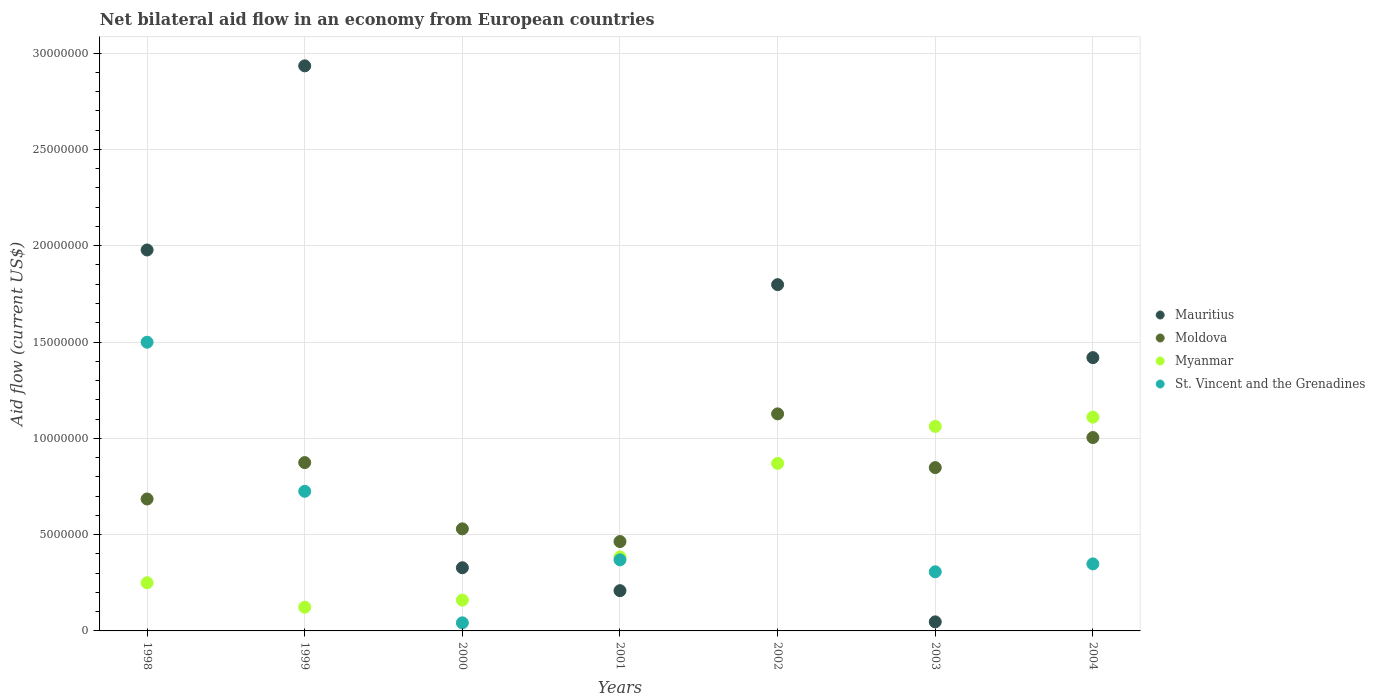How many different coloured dotlines are there?
Your response must be concise. 4. Is the number of dotlines equal to the number of legend labels?
Offer a terse response. No. What is the net bilateral aid flow in Myanmar in 1998?
Your answer should be compact. 2.50e+06. Across all years, what is the maximum net bilateral aid flow in St. Vincent and the Grenadines?
Your answer should be compact. 1.50e+07. Across all years, what is the minimum net bilateral aid flow in Mauritius?
Make the answer very short. 4.70e+05. What is the total net bilateral aid flow in Myanmar in the graph?
Keep it short and to the point. 3.96e+07. What is the difference between the net bilateral aid flow in St. Vincent and the Grenadines in 1998 and the net bilateral aid flow in Mauritius in 2002?
Make the answer very short. -2.99e+06. What is the average net bilateral aid flow in Myanmar per year?
Keep it short and to the point. 5.66e+06. In the year 2001, what is the difference between the net bilateral aid flow in St. Vincent and the Grenadines and net bilateral aid flow in Myanmar?
Provide a short and direct response. -1.50e+05. In how many years, is the net bilateral aid flow in Myanmar greater than 24000000 US$?
Make the answer very short. 0. What is the ratio of the net bilateral aid flow in Myanmar in 1998 to that in 1999?
Offer a very short reply. 2.03. What is the difference between the highest and the second highest net bilateral aid flow in St. Vincent and the Grenadines?
Your response must be concise. 7.74e+06. What is the difference between the highest and the lowest net bilateral aid flow in Mauritius?
Your response must be concise. 2.89e+07. In how many years, is the net bilateral aid flow in Myanmar greater than the average net bilateral aid flow in Myanmar taken over all years?
Keep it short and to the point. 3. Is it the case that in every year, the sum of the net bilateral aid flow in Moldova and net bilateral aid flow in St. Vincent and the Grenadines  is greater than the sum of net bilateral aid flow in Myanmar and net bilateral aid flow in Mauritius?
Ensure brevity in your answer.  No. Does the net bilateral aid flow in Myanmar monotonically increase over the years?
Offer a terse response. No. How many years are there in the graph?
Your response must be concise. 7. What is the difference between two consecutive major ticks on the Y-axis?
Your answer should be very brief. 5.00e+06. Where does the legend appear in the graph?
Ensure brevity in your answer.  Center right. How many legend labels are there?
Provide a succinct answer. 4. What is the title of the graph?
Your response must be concise. Net bilateral aid flow in an economy from European countries. What is the label or title of the X-axis?
Ensure brevity in your answer.  Years. What is the Aid flow (current US$) of Mauritius in 1998?
Your response must be concise. 1.98e+07. What is the Aid flow (current US$) in Moldova in 1998?
Ensure brevity in your answer.  6.85e+06. What is the Aid flow (current US$) in Myanmar in 1998?
Offer a very short reply. 2.50e+06. What is the Aid flow (current US$) in St. Vincent and the Grenadines in 1998?
Your answer should be compact. 1.50e+07. What is the Aid flow (current US$) in Mauritius in 1999?
Provide a succinct answer. 2.93e+07. What is the Aid flow (current US$) of Moldova in 1999?
Ensure brevity in your answer.  8.74e+06. What is the Aid flow (current US$) of Myanmar in 1999?
Give a very brief answer. 1.23e+06. What is the Aid flow (current US$) in St. Vincent and the Grenadines in 1999?
Your answer should be compact. 7.25e+06. What is the Aid flow (current US$) of Mauritius in 2000?
Offer a very short reply. 3.28e+06. What is the Aid flow (current US$) of Moldova in 2000?
Provide a succinct answer. 5.30e+06. What is the Aid flow (current US$) in Myanmar in 2000?
Provide a short and direct response. 1.60e+06. What is the Aid flow (current US$) in St. Vincent and the Grenadines in 2000?
Offer a terse response. 4.20e+05. What is the Aid flow (current US$) in Mauritius in 2001?
Your answer should be very brief. 2.09e+06. What is the Aid flow (current US$) of Moldova in 2001?
Offer a terse response. 4.64e+06. What is the Aid flow (current US$) of Myanmar in 2001?
Your answer should be compact. 3.84e+06. What is the Aid flow (current US$) in St. Vincent and the Grenadines in 2001?
Provide a succinct answer. 3.69e+06. What is the Aid flow (current US$) in Mauritius in 2002?
Give a very brief answer. 1.80e+07. What is the Aid flow (current US$) in Moldova in 2002?
Offer a very short reply. 1.13e+07. What is the Aid flow (current US$) in Myanmar in 2002?
Offer a very short reply. 8.70e+06. What is the Aid flow (current US$) in Mauritius in 2003?
Provide a succinct answer. 4.70e+05. What is the Aid flow (current US$) in Moldova in 2003?
Offer a very short reply. 8.48e+06. What is the Aid flow (current US$) in Myanmar in 2003?
Your answer should be very brief. 1.06e+07. What is the Aid flow (current US$) in St. Vincent and the Grenadines in 2003?
Your response must be concise. 3.07e+06. What is the Aid flow (current US$) in Mauritius in 2004?
Your answer should be very brief. 1.42e+07. What is the Aid flow (current US$) of Moldova in 2004?
Your response must be concise. 1.00e+07. What is the Aid flow (current US$) in Myanmar in 2004?
Keep it short and to the point. 1.11e+07. What is the Aid flow (current US$) of St. Vincent and the Grenadines in 2004?
Provide a succinct answer. 3.48e+06. Across all years, what is the maximum Aid flow (current US$) in Mauritius?
Offer a terse response. 2.93e+07. Across all years, what is the maximum Aid flow (current US$) in Moldova?
Your answer should be compact. 1.13e+07. Across all years, what is the maximum Aid flow (current US$) in Myanmar?
Your answer should be compact. 1.11e+07. Across all years, what is the maximum Aid flow (current US$) of St. Vincent and the Grenadines?
Make the answer very short. 1.50e+07. Across all years, what is the minimum Aid flow (current US$) in Moldova?
Your answer should be compact. 4.64e+06. Across all years, what is the minimum Aid flow (current US$) in Myanmar?
Your answer should be compact. 1.23e+06. What is the total Aid flow (current US$) in Mauritius in the graph?
Your answer should be very brief. 8.71e+07. What is the total Aid flow (current US$) in Moldova in the graph?
Make the answer very short. 5.53e+07. What is the total Aid flow (current US$) in Myanmar in the graph?
Make the answer very short. 3.96e+07. What is the total Aid flow (current US$) in St. Vincent and the Grenadines in the graph?
Your response must be concise. 3.29e+07. What is the difference between the Aid flow (current US$) of Mauritius in 1998 and that in 1999?
Your answer should be compact. -9.56e+06. What is the difference between the Aid flow (current US$) in Moldova in 1998 and that in 1999?
Offer a terse response. -1.89e+06. What is the difference between the Aid flow (current US$) of Myanmar in 1998 and that in 1999?
Keep it short and to the point. 1.27e+06. What is the difference between the Aid flow (current US$) of St. Vincent and the Grenadines in 1998 and that in 1999?
Provide a succinct answer. 7.74e+06. What is the difference between the Aid flow (current US$) of Mauritius in 1998 and that in 2000?
Offer a terse response. 1.65e+07. What is the difference between the Aid flow (current US$) in Moldova in 1998 and that in 2000?
Keep it short and to the point. 1.55e+06. What is the difference between the Aid flow (current US$) of St. Vincent and the Grenadines in 1998 and that in 2000?
Your answer should be very brief. 1.46e+07. What is the difference between the Aid flow (current US$) of Mauritius in 1998 and that in 2001?
Make the answer very short. 1.77e+07. What is the difference between the Aid flow (current US$) in Moldova in 1998 and that in 2001?
Your response must be concise. 2.21e+06. What is the difference between the Aid flow (current US$) of Myanmar in 1998 and that in 2001?
Give a very brief answer. -1.34e+06. What is the difference between the Aid flow (current US$) of St. Vincent and the Grenadines in 1998 and that in 2001?
Make the answer very short. 1.13e+07. What is the difference between the Aid flow (current US$) in Mauritius in 1998 and that in 2002?
Your answer should be compact. 1.80e+06. What is the difference between the Aid flow (current US$) in Moldova in 1998 and that in 2002?
Make the answer very short. -4.42e+06. What is the difference between the Aid flow (current US$) in Myanmar in 1998 and that in 2002?
Offer a very short reply. -6.20e+06. What is the difference between the Aid flow (current US$) in Mauritius in 1998 and that in 2003?
Make the answer very short. 1.93e+07. What is the difference between the Aid flow (current US$) of Moldova in 1998 and that in 2003?
Your answer should be compact. -1.63e+06. What is the difference between the Aid flow (current US$) in Myanmar in 1998 and that in 2003?
Your response must be concise. -8.12e+06. What is the difference between the Aid flow (current US$) of St. Vincent and the Grenadines in 1998 and that in 2003?
Your answer should be compact. 1.19e+07. What is the difference between the Aid flow (current US$) of Mauritius in 1998 and that in 2004?
Your answer should be very brief. 5.59e+06. What is the difference between the Aid flow (current US$) in Moldova in 1998 and that in 2004?
Keep it short and to the point. -3.19e+06. What is the difference between the Aid flow (current US$) of Myanmar in 1998 and that in 2004?
Ensure brevity in your answer.  -8.60e+06. What is the difference between the Aid flow (current US$) in St. Vincent and the Grenadines in 1998 and that in 2004?
Give a very brief answer. 1.15e+07. What is the difference between the Aid flow (current US$) in Mauritius in 1999 and that in 2000?
Offer a very short reply. 2.61e+07. What is the difference between the Aid flow (current US$) in Moldova in 1999 and that in 2000?
Your answer should be compact. 3.44e+06. What is the difference between the Aid flow (current US$) of Myanmar in 1999 and that in 2000?
Provide a short and direct response. -3.70e+05. What is the difference between the Aid flow (current US$) in St. Vincent and the Grenadines in 1999 and that in 2000?
Make the answer very short. 6.83e+06. What is the difference between the Aid flow (current US$) in Mauritius in 1999 and that in 2001?
Offer a terse response. 2.72e+07. What is the difference between the Aid flow (current US$) of Moldova in 1999 and that in 2001?
Offer a terse response. 4.10e+06. What is the difference between the Aid flow (current US$) of Myanmar in 1999 and that in 2001?
Ensure brevity in your answer.  -2.61e+06. What is the difference between the Aid flow (current US$) of St. Vincent and the Grenadines in 1999 and that in 2001?
Your response must be concise. 3.56e+06. What is the difference between the Aid flow (current US$) of Mauritius in 1999 and that in 2002?
Provide a succinct answer. 1.14e+07. What is the difference between the Aid flow (current US$) of Moldova in 1999 and that in 2002?
Your answer should be compact. -2.53e+06. What is the difference between the Aid flow (current US$) of Myanmar in 1999 and that in 2002?
Your answer should be very brief. -7.47e+06. What is the difference between the Aid flow (current US$) of Mauritius in 1999 and that in 2003?
Your answer should be compact. 2.89e+07. What is the difference between the Aid flow (current US$) in Moldova in 1999 and that in 2003?
Offer a terse response. 2.60e+05. What is the difference between the Aid flow (current US$) of Myanmar in 1999 and that in 2003?
Offer a very short reply. -9.39e+06. What is the difference between the Aid flow (current US$) of St. Vincent and the Grenadines in 1999 and that in 2003?
Make the answer very short. 4.18e+06. What is the difference between the Aid flow (current US$) in Mauritius in 1999 and that in 2004?
Offer a very short reply. 1.52e+07. What is the difference between the Aid flow (current US$) of Moldova in 1999 and that in 2004?
Offer a very short reply. -1.30e+06. What is the difference between the Aid flow (current US$) in Myanmar in 1999 and that in 2004?
Your response must be concise. -9.87e+06. What is the difference between the Aid flow (current US$) in St. Vincent and the Grenadines in 1999 and that in 2004?
Offer a terse response. 3.77e+06. What is the difference between the Aid flow (current US$) of Mauritius in 2000 and that in 2001?
Offer a very short reply. 1.19e+06. What is the difference between the Aid flow (current US$) in Myanmar in 2000 and that in 2001?
Your response must be concise. -2.24e+06. What is the difference between the Aid flow (current US$) of St. Vincent and the Grenadines in 2000 and that in 2001?
Ensure brevity in your answer.  -3.27e+06. What is the difference between the Aid flow (current US$) in Mauritius in 2000 and that in 2002?
Provide a succinct answer. -1.47e+07. What is the difference between the Aid flow (current US$) in Moldova in 2000 and that in 2002?
Your answer should be very brief. -5.97e+06. What is the difference between the Aid flow (current US$) in Myanmar in 2000 and that in 2002?
Offer a very short reply. -7.10e+06. What is the difference between the Aid flow (current US$) of Mauritius in 2000 and that in 2003?
Your response must be concise. 2.81e+06. What is the difference between the Aid flow (current US$) in Moldova in 2000 and that in 2003?
Your answer should be very brief. -3.18e+06. What is the difference between the Aid flow (current US$) of Myanmar in 2000 and that in 2003?
Your answer should be very brief. -9.02e+06. What is the difference between the Aid flow (current US$) in St. Vincent and the Grenadines in 2000 and that in 2003?
Ensure brevity in your answer.  -2.65e+06. What is the difference between the Aid flow (current US$) in Mauritius in 2000 and that in 2004?
Ensure brevity in your answer.  -1.09e+07. What is the difference between the Aid flow (current US$) in Moldova in 2000 and that in 2004?
Give a very brief answer. -4.74e+06. What is the difference between the Aid flow (current US$) in Myanmar in 2000 and that in 2004?
Provide a succinct answer. -9.50e+06. What is the difference between the Aid flow (current US$) in St. Vincent and the Grenadines in 2000 and that in 2004?
Your answer should be very brief. -3.06e+06. What is the difference between the Aid flow (current US$) of Mauritius in 2001 and that in 2002?
Your answer should be compact. -1.59e+07. What is the difference between the Aid flow (current US$) of Moldova in 2001 and that in 2002?
Your answer should be compact. -6.63e+06. What is the difference between the Aid flow (current US$) in Myanmar in 2001 and that in 2002?
Offer a terse response. -4.86e+06. What is the difference between the Aid flow (current US$) of Mauritius in 2001 and that in 2003?
Offer a terse response. 1.62e+06. What is the difference between the Aid flow (current US$) in Moldova in 2001 and that in 2003?
Make the answer very short. -3.84e+06. What is the difference between the Aid flow (current US$) in Myanmar in 2001 and that in 2003?
Make the answer very short. -6.78e+06. What is the difference between the Aid flow (current US$) of St. Vincent and the Grenadines in 2001 and that in 2003?
Your response must be concise. 6.20e+05. What is the difference between the Aid flow (current US$) of Mauritius in 2001 and that in 2004?
Keep it short and to the point. -1.21e+07. What is the difference between the Aid flow (current US$) of Moldova in 2001 and that in 2004?
Provide a succinct answer. -5.40e+06. What is the difference between the Aid flow (current US$) in Myanmar in 2001 and that in 2004?
Give a very brief answer. -7.26e+06. What is the difference between the Aid flow (current US$) of St. Vincent and the Grenadines in 2001 and that in 2004?
Your answer should be very brief. 2.10e+05. What is the difference between the Aid flow (current US$) in Mauritius in 2002 and that in 2003?
Provide a short and direct response. 1.75e+07. What is the difference between the Aid flow (current US$) of Moldova in 2002 and that in 2003?
Provide a succinct answer. 2.79e+06. What is the difference between the Aid flow (current US$) in Myanmar in 2002 and that in 2003?
Make the answer very short. -1.92e+06. What is the difference between the Aid flow (current US$) in Mauritius in 2002 and that in 2004?
Provide a short and direct response. 3.79e+06. What is the difference between the Aid flow (current US$) in Moldova in 2002 and that in 2004?
Keep it short and to the point. 1.23e+06. What is the difference between the Aid flow (current US$) in Myanmar in 2002 and that in 2004?
Offer a terse response. -2.40e+06. What is the difference between the Aid flow (current US$) in Mauritius in 2003 and that in 2004?
Ensure brevity in your answer.  -1.37e+07. What is the difference between the Aid flow (current US$) of Moldova in 2003 and that in 2004?
Provide a short and direct response. -1.56e+06. What is the difference between the Aid flow (current US$) of Myanmar in 2003 and that in 2004?
Provide a short and direct response. -4.80e+05. What is the difference between the Aid flow (current US$) of St. Vincent and the Grenadines in 2003 and that in 2004?
Offer a very short reply. -4.10e+05. What is the difference between the Aid flow (current US$) of Mauritius in 1998 and the Aid flow (current US$) of Moldova in 1999?
Give a very brief answer. 1.10e+07. What is the difference between the Aid flow (current US$) in Mauritius in 1998 and the Aid flow (current US$) in Myanmar in 1999?
Keep it short and to the point. 1.86e+07. What is the difference between the Aid flow (current US$) in Mauritius in 1998 and the Aid flow (current US$) in St. Vincent and the Grenadines in 1999?
Provide a succinct answer. 1.25e+07. What is the difference between the Aid flow (current US$) of Moldova in 1998 and the Aid flow (current US$) of Myanmar in 1999?
Provide a short and direct response. 5.62e+06. What is the difference between the Aid flow (current US$) of Moldova in 1998 and the Aid flow (current US$) of St. Vincent and the Grenadines in 1999?
Your answer should be compact. -4.00e+05. What is the difference between the Aid flow (current US$) of Myanmar in 1998 and the Aid flow (current US$) of St. Vincent and the Grenadines in 1999?
Your answer should be compact. -4.75e+06. What is the difference between the Aid flow (current US$) of Mauritius in 1998 and the Aid flow (current US$) of Moldova in 2000?
Offer a terse response. 1.45e+07. What is the difference between the Aid flow (current US$) in Mauritius in 1998 and the Aid flow (current US$) in Myanmar in 2000?
Your answer should be compact. 1.82e+07. What is the difference between the Aid flow (current US$) of Mauritius in 1998 and the Aid flow (current US$) of St. Vincent and the Grenadines in 2000?
Your answer should be compact. 1.94e+07. What is the difference between the Aid flow (current US$) in Moldova in 1998 and the Aid flow (current US$) in Myanmar in 2000?
Give a very brief answer. 5.25e+06. What is the difference between the Aid flow (current US$) in Moldova in 1998 and the Aid flow (current US$) in St. Vincent and the Grenadines in 2000?
Your answer should be compact. 6.43e+06. What is the difference between the Aid flow (current US$) in Myanmar in 1998 and the Aid flow (current US$) in St. Vincent and the Grenadines in 2000?
Your answer should be compact. 2.08e+06. What is the difference between the Aid flow (current US$) of Mauritius in 1998 and the Aid flow (current US$) of Moldova in 2001?
Offer a very short reply. 1.51e+07. What is the difference between the Aid flow (current US$) of Mauritius in 1998 and the Aid flow (current US$) of Myanmar in 2001?
Your answer should be compact. 1.59e+07. What is the difference between the Aid flow (current US$) of Mauritius in 1998 and the Aid flow (current US$) of St. Vincent and the Grenadines in 2001?
Your answer should be very brief. 1.61e+07. What is the difference between the Aid flow (current US$) of Moldova in 1998 and the Aid flow (current US$) of Myanmar in 2001?
Provide a succinct answer. 3.01e+06. What is the difference between the Aid flow (current US$) of Moldova in 1998 and the Aid flow (current US$) of St. Vincent and the Grenadines in 2001?
Keep it short and to the point. 3.16e+06. What is the difference between the Aid flow (current US$) in Myanmar in 1998 and the Aid flow (current US$) in St. Vincent and the Grenadines in 2001?
Your response must be concise. -1.19e+06. What is the difference between the Aid flow (current US$) of Mauritius in 1998 and the Aid flow (current US$) of Moldova in 2002?
Offer a very short reply. 8.51e+06. What is the difference between the Aid flow (current US$) in Mauritius in 1998 and the Aid flow (current US$) in Myanmar in 2002?
Keep it short and to the point. 1.11e+07. What is the difference between the Aid flow (current US$) in Moldova in 1998 and the Aid flow (current US$) in Myanmar in 2002?
Give a very brief answer. -1.85e+06. What is the difference between the Aid flow (current US$) of Mauritius in 1998 and the Aid flow (current US$) of Moldova in 2003?
Make the answer very short. 1.13e+07. What is the difference between the Aid flow (current US$) in Mauritius in 1998 and the Aid flow (current US$) in Myanmar in 2003?
Ensure brevity in your answer.  9.16e+06. What is the difference between the Aid flow (current US$) of Mauritius in 1998 and the Aid flow (current US$) of St. Vincent and the Grenadines in 2003?
Provide a short and direct response. 1.67e+07. What is the difference between the Aid flow (current US$) of Moldova in 1998 and the Aid flow (current US$) of Myanmar in 2003?
Give a very brief answer. -3.77e+06. What is the difference between the Aid flow (current US$) in Moldova in 1998 and the Aid flow (current US$) in St. Vincent and the Grenadines in 2003?
Keep it short and to the point. 3.78e+06. What is the difference between the Aid flow (current US$) of Myanmar in 1998 and the Aid flow (current US$) of St. Vincent and the Grenadines in 2003?
Your answer should be very brief. -5.70e+05. What is the difference between the Aid flow (current US$) of Mauritius in 1998 and the Aid flow (current US$) of Moldova in 2004?
Provide a short and direct response. 9.74e+06. What is the difference between the Aid flow (current US$) in Mauritius in 1998 and the Aid flow (current US$) in Myanmar in 2004?
Keep it short and to the point. 8.68e+06. What is the difference between the Aid flow (current US$) in Mauritius in 1998 and the Aid flow (current US$) in St. Vincent and the Grenadines in 2004?
Provide a succinct answer. 1.63e+07. What is the difference between the Aid flow (current US$) in Moldova in 1998 and the Aid flow (current US$) in Myanmar in 2004?
Your response must be concise. -4.25e+06. What is the difference between the Aid flow (current US$) of Moldova in 1998 and the Aid flow (current US$) of St. Vincent and the Grenadines in 2004?
Your answer should be very brief. 3.37e+06. What is the difference between the Aid flow (current US$) in Myanmar in 1998 and the Aid flow (current US$) in St. Vincent and the Grenadines in 2004?
Your response must be concise. -9.80e+05. What is the difference between the Aid flow (current US$) in Mauritius in 1999 and the Aid flow (current US$) in Moldova in 2000?
Your response must be concise. 2.40e+07. What is the difference between the Aid flow (current US$) in Mauritius in 1999 and the Aid flow (current US$) in Myanmar in 2000?
Make the answer very short. 2.77e+07. What is the difference between the Aid flow (current US$) of Mauritius in 1999 and the Aid flow (current US$) of St. Vincent and the Grenadines in 2000?
Your answer should be compact. 2.89e+07. What is the difference between the Aid flow (current US$) in Moldova in 1999 and the Aid flow (current US$) in Myanmar in 2000?
Give a very brief answer. 7.14e+06. What is the difference between the Aid flow (current US$) in Moldova in 1999 and the Aid flow (current US$) in St. Vincent and the Grenadines in 2000?
Ensure brevity in your answer.  8.32e+06. What is the difference between the Aid flow (current US$) in Myanmar in 1999 and the Aid flow (current US$) in St. Vincent and the Grenadines in 2000?
Give a very brief answer. 8.10e+05. What is the difference between the Aid flow (current US$) of Mauritius in 1999 and the Aid flow (current US$) of Moldova in 2001?
Your response must be concise. 2.47e+07. What is the difference between the Aid flow (current US$) of Mauritius in 1999 and the Aid flow (current US$) of Myanmar in 2001?
Ensure brevity in your answer.  2.55e+07. What is the difference between the Aid flow (current US$) in Mauritius in 1999 and the Aid flow (current US$) in St. Vincent and the Grenadines in 2001?
Keep it short and to the point. 2.56e+07. What is the difference between the Aid flow (current US$) of Moldova in 1999 and the Aid flow (current US$) of Myanmar in 2001?
Make the answer very short. 4.90e+06. What is the difference between the Aid flow (current US$) in Moldova in 1999 and the Aid flow (current US$) in St. Vincent and the Grenadines in 2001?
Ensure brevity in your answer.  5.05e+06. What is the difference between the Aid flow (current US$) of Myanmar in 1999 and the Aid flow (current US$) of St. Vincent and the Grenadines in 2001?
Provide a short and direct response. -2.46e+06. What is the difference between the Aid flow (current US$) in Mauritius in 1999 and the Aid flow (current US$) in Moldova in 2002?
Provide a short and direct response. 1.81e+07. What is the difference between the Aid flow (current US$) in Mauritius in 1999 and the Aid flow (current US$) in Myanmar in 2002?
Give a very brief answer. 2.06e+07. What is the difference between the Aid flow (current US$) in Moldova in 1999 and the Aid flow (current US$) in Myanmar in 2002?
Provide a succinct answer. 4.00e+04. What is the difference between the Aid flow (current US$) of Mauritius in 1999 and the Aid flow (current US$) of Moldova in 2003?
Your response must be concise. 2.09e+07. What is the difference between the Aid flow (current US$) of Mauritius in 1999 and the Aid flow (current US$) of Myanmar in 2003?
Make the answer very short. 1.87e+07. What is the difference between the Aid flow (current US$) of Mauritius in 1999 and the Aid flow (current US$) of St. Vincent and the Grenadines in 2003?
Ensure brevity in your answer.  2.63e+07. What is the difference between the Aid flow (current US$) of Moldova in 1999 and the Aid flow (current US$) of Myanmar in 2003?
Provide a succinct answer. -1.88e+06. What is the difference between the Aid flow (current US$) of Moldova in 1999 and the Aid flow (current US$) of St. Vincent and the Grenadines in 2003?
Provide a short and direct response. 5.67e+06. What is the difference between the Aid flow (current US$) of Myanmar in 1999 and the Aid flow (current US$) of St. Vincent and the Grenadines in 2003?
Make the answer very short. -1.84e+06. What is the difference between the Aid flow (current US$) of Mauritius in 1999 and the Aid flow (current US$) of Moldova in 2004?
Your answer should be compact. 1.93e+07. What is the difference between the Aid flow (current US$) in Mauritius in 1999 and the Aid flow (current US$) in Myanmar in 2004?
Offer a very short reply. 1.82e+07. What is the difference between the Aid flow (current US$) in Mauritius in 1999 and the Aid flow (current US$) in St. Vincent and the Grenadines in 2004?
Make the answer very short. 2.59e+07. What is the difference between the Aid flow (current US$) in Moldova in 1999 and the Aid flow (current US$) in Myanmar in 2004?
Ensure brevity in your answer.  -2.36e+06. What is the difference between the Aid flow (current US$) of Moldova in 1999 and the Aid flow (current US$) of St. Vincent and the Grenadines in 2004?
Make the answer very short. 5.26e+06. What is the difference between the Aid flow (current US$) in Myanmar in 1999 and the Aid flow (current US$) in St. Vincent and the Grenadines in 2004?
Your answer should be compact. -2.25e+06. What is the difference between the Aid flow (current US$) in Mauritius in 2000 and the Aid flow (current US$) in Moldova in 2001?
Provide a short and direct response. -1.36e+06. What is the difference between the Aid flow (current US$) in Mauritius in 2000 and the Aid flow (current US$) in Myanmar in 2001?
Offer a very short reply. -5.60e+05. What is the difference between the Aid flow (current US$) in Mauritius in 2000 and the Aid flow (current US$) in St. Vincent and the Grenadines in 2001?
Your answer should be compact. -4.10e+05. What is the difference between the Aid flow (current US$) of Moldova in 2000 and the Aid flow (current US$) of Myanmar in 2001?
Offer a terse response. 1.46e+06. What is the difference between the Aid flow (current US$) of Moldova in 2000 and the Aid flow (current US$) of St. Vincent and the Grenadines in 2001?
Offer a terse response. 1.61e+06. What is the difference between the Aid flow (current US$) of Myanmar in 2000 and the Aid flow (current US$) of St. Vincent and the Grenadines in 2001?
Provide a short and direct response. -2.09e+06. What is the difference between the Aid flow (current US$) of Mauritius in 2000 and the Aid flow (current US$) of Moldova in 2002?
Provide a short and direct response. -7.99e+06. What is the difference between the Aid flow (current US$) in Mauritius in 2000 and the Aid flow (current US$) in Myanmar in 2002?
Provide a succinct answer. -5.42e+06. What is the difference between the Aid flow (current US$) in Moldova in 2000 and the Aid flow (current US$) in Myanmar in 2002?
Ensure brevity in your answer.  -3.40e+06. What is the difference between the Aid flow (current US$) of Mauritius in 2000 and the Aid flow (current US$) of Moldova in 2003?
Provide a succinct answer. -5.20e+06. What is the difference between the Aid flow (current US$) in Mauritius in 2000 and the Aid flow (current US$) in Myanmar in 2003?
Provide a short and direct response. -7.34e+06. What is the difference between the Aid flow (current US$) in Mauritius in 2000 and the Aid flow (current US$) in St. Vincent and the Grenadines in 2003?
Your answer should be very brief. 2.10e+05. What is the difference between the Aid flow (current US$) in Moldova in 2000 and the Aid flow (current US$) in Myanmar in 2003?
Provide a short and direct response. -5.32e+06. What is the difference between the Aid flow (current US$) of Moldova in 2000 and the Aid flow (current US$) of St. Vincent and the Grenadines in 2003?
Your response must be concise. 2.23e+06. What is the difference between the Aid flow (current US$) of Myanmar in 2000 and the Aid flow (current US$) of St. Vincent and the Grenadines in 2003?
Offer a very short reply. -1.47e+06. What is the difference between the Aid flow (current US$) of Mauritius in 2000 and the Aid flow (current US$) of Moldova in 2004?
Offer a very short reply. -6.76e+06. What is the difference between the Aid flow (current US$) of Mauritius in 2000 and the Aid flow (current US$) of Myanmar in 2004?
Your answer should be very brief. -7.82e+06. What is the difference between the Aid flow (current US$) in Moldova in 2000 and the Aid flow (current US$) in Myanmar in 2004?
Ensure brevity in your answer.  -5.80e+06. What is the difference between the Aid flow (current US$) in Moldova in 2000 and the Aid flow (current US$) in St. Vincent and the Grenadines in 2004?
Your answer should be very brief. 1.82e+06. What is the difference between the Aid flow (current US$) of Myanmar in 2000 and the Aid flow (current US$) of St. Vincent and the Grenadines in 2004?
Provide a succinct answer. -1.88e+06. What is the difference between the Aid flow (current US$) in Mauritius in 2001 and the Aid flow (current US$) in Moldova in 2002?
Your answer should be very brief. -9.18e+06. What is the difference between the Aid flow (current US$) of Mauritius in 2001 and the Aid flow (current US$) of Myanmar in 2002?
Provide a short and direct response. -6.61e+06. What is the difference between the Aid flow (current US$) of Moldova in 2001 and the Aid flow (current US$) of Myanmar in 2002?
Provide a succinct answer. -4.06e+06. What is the difference between the Aid flow (current US$) of Mauritius in 2001 and the Aid flow (current US$) of Moldova in 2003?
Your answer should be compact. -6.39e+06. What is the difference between the Aid flow (current US$) of Mauritius in 2001 and the Aid flow (current US$) of Myanmar in 2003?
Offer a terse response. -8.53e+06. What is the difference between the Aid flow (current US$) in Mauritius in 2001 and the Aid flow (current US$) in St. Vincent and the Grenadines in 2003?
Your answer should be compact. -9.80e+05. What is the difference between the Aid flow (current US$) in Moldova in 2001 and the Aid flow (current US$) in Myanmar in 2003?
Your answer should be compact. -5.98e+06. What is the difference between the Aid flow (current US$) in Moldova in 2001 and the Aid flow (current US$) in St. Vincent and the Grenadines in 2003?
Your answer should be very brief. 1.57e+06. What is the difference between the Aid flow (current US$) of Myanmar in 2001 and the Aid flow (current US$) of St. Vincent and the Grenadines in 2003?
Provide a succinct answer. 7.70e+05. What is the difference between the Aid flow (current US$) in Mauritius in 2001 and the Aid flow (current US$) in Moldova in 2004?
Offer a terse response. -7.95e+06. What is the difference between the Aid flow (current US$) of Mauritius in 2001 and the Aid flow (current US$) of Myanmar in 2004?
Provide a succinct answer. -9.01e+06. What is the difference between the Aid flow (current US$) in Mauritius in 2001 and the Aid flow (current US$) in St. Vincent and the Grenadines in 2004?
Ensure brevity in your answer.  -1.39e+06. What is the difference between the Aid flow (current US$) of Moldova in 2001 and the Aid flow (current US$) of Myanmar in 2004?
Make the answer very short. -6.46e+06. What is the difference between the Aid flow (current US$) in Moldova in 2001 and the Aid flow (current US$) in St. Vincent and the Grenadines in 2004?
Provide a succinct answer. 1.16e+06. What is the difference between the Aid flow (current US$) in Mauritius in 2002 and the Aid flow (current US$) in Moldova in 2003?
Make the answer very short. 9.50e+06. What is the difference between the Aid flow (current US$) of Mauritius in 2002 and the Aid flow (current US$) of Myanmar in 2003?
Your response must be concise. 7.36e+06. What is the difference between the Aid flow (current US$) of Mauritius in 2002 and the Aid flow (current US$) of St. Vincent and the Grenadines in 2003?
Give a very brief answer. 1.49e+07. What is the difference between the Aid flow (current US$) of Moldova in 2002 and the Aid flow (current US$) of Myanmar in 2003?
Provide a short and direct response. 6.50e+05. What is the difference between the Aid flow (current US$) of Moldova in 2002 and the Aid flow (current US$) of St. Vincent and the Grenadines in 2003?
Provide a succinct answer. 8.20e+06. What is the difference between the Aid flow (current US$) in Myanmar in 2002 and the Aid flow (current US$) in St. Vincent and the Grenadines in 2003?
Ensure brevity in your answer.  5.63e+06. What is the difference between the Aid flow (current US$) in Mauritius in 2002 and the Aid flow (current US$) in Moldova in 2004?
Provide a succinct answer. 7.94e+06. What is the difference between the Aid flow (current US$) of Mauritius in 2002 and the Aid flow (current US$) of Myanmar in 2004?
Ensure brevity in your answer.  6.88e+06. What is the difference between the Aid flow (current US$) in Mauritius in 2002 and the Aid flow (current US$) in St. Vincent and the Grenadines in 2004?
Your answer should be very brief. 1.45e+07. What is the difference between the Aid flow (current US$) in Moldova in 2002 and the Aid flow (current US$) in St. Vincent and the Grenadines in 2004?
Ensure brevity in your answer.  7.79e+06. What is the difference between the Aid flow (current US$) of Myanmar in 2002 and the Aid flow (current US$) of St. Vincent and the Grenadines in 2004?
Offer a terse response. 5.22e+06. What is the difference between the Aid flow (current US$) in Mauritius in 2003 and the Aid flow (current US$) in Moldova in 2004?
Your answer should be compact. -9.57e+06. What is the difference between the Aid flow (current US$) in Mauritius in 2003 and the Aid flow (current US$) in Myanmar in 2004?
Provide a succinct answer. -1.06e+07. What is the difference between the Aid flow (current US$) in Mauritius in 2003 and the Aid flow (current US$) in St. Vincent and the Grenadines in 2004?
Your answer should be very brief. -3.01e+06. What is the difference between the Aid flow (current US$) of Moldova in 2003 and the Aid flow (current US$) of Myanmar in 2004?
Your answer should be compact. -2.62e+06. What is the difference between the Aid flow (current US$) of Moldova in 2003 and the Aid flow (current US$) of St. Vincent and the Grenadines in 2004?
Your answer should be compact. 5.00e+06. What is the difference between the Aid flow (current US$) of Myanmar in 2003 and the Aid flow (current US$) of St. Vincent and the Grenadines in 2004?
Make the answer very short. 7.14e+06. What is the average Aid flow (current US$) of Mauritius per year?
Give a very brief answer. 1.24e+07. What is the average Aid flow (current US$) in Moldova per year?
Offer a very short reply. 7.90e+06. What is the average Aid flow (current US$) of Myanmar per year?
Provide a short and direct response. 5.66e+06. What is the average Aid flow (current US$) of St. Vincent and the Grenadines per year?
Ensure brevity in your answer.  4.70e+06. In the year 1998, what is the difference between the Aid flow (current US$) of Mauritius and Aid flow (current US$) of Moldova?
Keep it short and to the point. 1.29e+07. In the year 1998, what is the difference between the Aid flow (current US$) in Mauritius and Aid flow (current US$) in Myanmar?
Offer a very short reply. 1.73e+07. In the year 1998, what is the difference between the Aid flow (current US$) of Mauritius and Aid flow (current US$) of St. Vincent and the Grenadines?
Your answer should be very brief. 4.79e+06. In the year 1998, what is the difference between the Aid flow (current US$) in Moldova and Aid flow (current US$) in Myanmar?
Offer a terse response. 4.35e+06. In the year 1998, what is the difference between the Aid flow (current US$) in Moldova and Aid flow (current US$) in St. Vincent and the Grenadines?
Offer a very short reply. -8.14e+06. In the year 1998, what is the difference between the Aid flow (current US$) of Myanmar and Aid flow (current US$) of St. Vincent and the Grenadines?
Ensure brevity in your answer.  -1.25e+07. In the year 1999, what is the difference between the Aid flow (current US$) of Mauritius and Aid flow (current US$) of Moldova?
Offer a terse response. 2.06e+07. In the year 1999, what is the difference between the Aid flow (current US$) of Mauritius and Aid flow (current US$) of Myanmar?
Your answer should be very brief. 2.81e+07. In the year 1999, what is the difference between the Aid flow (current US$) in Mauritius and Aid flow (current US$) in St. Vincent and the Grenadines?
Make the answer very short. 2.21e+07. In the year 1999, what is the difference between the Aid flow (current US$) of Moldova and Aid flow (current US$) of Myanmar?
Offer a terse response. 7.51e+06. In the year 1999, what is the difference between the Aid flow (current US$) of Moldova and Aid flow (current US$) of St. Vincent and the Grenadines?
Provide a short and direct response. 1.49e+06. In the year 1999, what is the difference between the Aid flow (current US$) of Myanmar and Aid flow (current US$) of St. Vincent and the Grenadines?
Provide a succinct answer. -6.02e+06. In the year 2000, what is the difference between the Aid flow (current US$) of Mauritius and Aid flow (current US$) of Moldova?
Provide a succinct answer. -2.02e+06. In the year 2000, what is the difference between the Aid flow (current US$) in Mauritius and Aid flow (current US$) in Myanmar?
Keep it short and to the point. 1.68e+06. In the year 2000, what is the difference between the Aid flow (current US$) of Mauritius and Aid flow (current US$) of St. Vincent and the Grenadines?
Offer a very short reply. 2.86e+06. In the year 2000, what is the difference between the Aid flow (current US$) of Moldova and Aid flow (current US$) of Myanmar?
Provide a succinct answer. 3.70e+06. In the year 2000, what is the difference between the Aid flow (current US$) in Moldova and Aid flow (current US$) in St. Vincent and the Grenadines?
Provide a succinct answer. 4.88e+06. In the year 2000, what is the difference between the Aid flow (current US$) of Myanmar and Aid flow (current US$) of St. Vincent and the Grenadines?
Your answer should be compact. 1.18e+06. In the year 2001, what is the difference between the Aid flow (current US$) of Mauritius and Aid flow (current US$) of Moldova?
Provide a short and direct response. -2.55e+06. In the year 2001, what is the difference between the Aid flow (current US$) in Mauritius and Aid flow (current US$) in Myanmar?
Provide a succinct answer. -1.75e+06. In the year 2001, what is the difference between the Aid flow (current US$) in Mauritius and Aid flow (current US$) in St. Vincent and the Grenadines?
Offer a very short reply. -1.60e+06. In the year 2001, what is the difference between the Aid flow (current US$) of Moldova and Aid flow (current US$) of Myanmar?
Your response must be concise. 8.00e+05. In the year 2001, what is the difference between the Aid flow (current US$) in Moldova and Aid flow (current US$) in St. Vincent and the Grenadines?
Offer a very short reply. 9.50e+05. In the year 2002, what is the difference between the Aid flow (current US$) of Mauritius and Aid flow (current US$) of Moldova?
Make the answer very short. 6.71e+06. In the year 2002, what is the difference between the Aid flow (current US$) of Mauritius and Aid flow (current US$) of Myanmar?
Make the answer very short. 9.28e+06. In the year 2002, what is the difference between the Aid flow (current US$) of Moldova and Aid flow (current US$) of Myanmar?
Your answer should be very brief. 2.57e+06. In the year 2003, what is the difference between the Aid flow (current US$) in Mauritius and Aid flow (current US$) in Moldova?
Give a very brief answer. -8.01e+06. In the year 2003, what is the difference between the Aid flow (current US$) in Mauritius and Aid flow (current US$) in Myanmar?
Your response must be concise. -1.02e+07. In the year 2003, what is the difference between the Aid flow (current US$) in Mauritius and Aid flow (current US$) in St. Vincent and the Grenadines?
Your answer should be compact. -2.60e+06. In the year 2003, what is the difference between the Aid flow (current US$) in Moldova and Aid flow (current US$) in Myanmar?
Your response must be concise. -2.14e+06. In the year 2003, what is the difference between the Aid flow (current US$) of Moldova and Aid flow (current US$) of St. Vincent and the Grenadines?
Make the answer very short. 5.41e+06. In the year 2003, what is the difference between the Aid flow (current US$) of Myanmar and Aid flow (current US$) of St. Vincent and the Grenadines?
Give a very brief answer. 7.55e+06. In the year 2004, what is the difference between the Aid flow (current US$) in Mauritius and Aid flow (current US$) in Moldova?
Your answer should be very brief. 4.15e+06. In the year 2004, what is the difference between the Aid flow (current US$) of Mauritius and Aid flow (current US$) of Myanmar?
Your response must be concise. 3.09e+06. In the year 2004, what is the difference between the Aid flow (current US$) of Mauritius and Aid flow (current US$) of St. Vincent and the Grenadines?
Give a very brief answer. 1.07e+07. In the year 2004, what is the difference between the Aid flow (current US$) in Moldova and Aid flow (current US$) in Myanmar?
Provide a succinct answer. -1.06e+06. In the year 2004, what is the difference between the Aid flow (current US$) of Moldova and Aid flow (current US$) of St. Vincent and the Grenadines?
Keep it short and to the point. 6.56e+06. In the year 2004, what is the difference between the Aid flow (current US$) in Myanmar and Aid flow (current US$) in St. Vincent and the Grenadines?
Provide a short and direct response. 7.62e+06. What is the ratio of the Aid flow (current US$) in Mauritius in 1998 to that in 1999?
Keep it short and to the point. 0.67. What is the ratio of the Aid flow (current US$) in Moldova in 1998 to that in 1999?
Keep it short and to the point. 0.78. What is the ratio of the Aid flow (current US$) in Myanmar in 1998 to that in 1999?
Your response must be concise. 2.03. What is the ratio of the Aid flow (current US$) of St. Vincent and the Grenadines in 1998 to that in 1999?
Your response must be concise. 2.07. What is the ratio of the Aid flow (current US$) of Mauritius in 1998 to that in 2000?
Your response must be concise. 6.03. What is the ratio of the Aid flow (current US$) of Moldova in 1998 to that in 2000?
Provide a succinct answer. 1.29. What is the ratio of the Aid flow (current US$) of Myanmar in 1998 to that in 2000?
Your response must be concise. 1.56. What is the ratio of the Aid flow (current US$) in St. Vincent and the Grenadines in 1998 to that in 2000?
Offer a terse response. 35.69. What is the ratio of the Aid flow (current US$) in Mauritius in 1998 to that in 2001?
Give a very brief answer. 9.46. What is the ratio of the Aid flow (current US$) of Moldova in 1998 to that in 2001?
Provide a short and direct response. 1.48. What is the ratio of the Aid flow (current US$) in Myanmar in 1998 to that in 2001?
Offer a very short reply. 0.65. What is the ratio of the Aid flow (current US$) of St. Vincent and the Grenadines in 1998 to that in 2001?
Make the answer very short. 4.06. What is the ratio of the Aid flow (current US$) in Mauritius in 1998 to that in 2002?
Offer a terse response. 1.1. What is the ratio of the Aid flow (current US$) of Moldova in 1998 to that in 2002?
Offer a very short reply. 0.61. What is the ratio of the Aid flow (current US$) in Myanmar in 1998 to that in 2002?
Make the answer very short. 0.29. What is the ratio of the Aid flow (current US$) of Mauritius in 1998 to that in 2003?
Keep it short and to the point. 42.09. What is the ratio of the Aid flow (current US$) of Moldova in 1998 to that in 2003?
Your answer should be very brief. 0.81. What is the ratio of the Aid flow (current US$) in Myanmar in 1998 to that in 2003?
Provide a short and direct response. 0.24. What is the ratio of the Aid flow (current US$) of St. Vincent and the Grenadines in 1998 to that in 2003?
Offer a very short reply. 4.88. What is the ratio of the Aid flow (current US$) in Mauritius in 1998 to that in 2004?
Offer a terse response. 1.39. What is the ratio of the Aid flow (current US$) in Moldova in 1998 to that in 2004?
Your response must be concise. 0.68. What is the ratio of the Aid flow (current US$) of Myanmar in 1998 to that in 2004?
Make the answer very short. 0.23. What is the ratio of the Aid flow (current US$) of St. Vincent and the Grenadines in 1998 to that in 2004?
Keep it short and to the point. 4.31. What is the ratio of the Aid flow (current US$) in Mauritius in 1999 to that in 2000?
Your response must be concise. 8.95. What is the ratio of the Aid flow (current US$) in Moldova in 1999 to that in 2000?
Your answer should be very brief. 1.65. What is the ratio of the Aid flow (current US$) of Myanmar in 1999 to that in 2000?
Offer a terse response. 0.77. What is the ratio of the Aid flow (current US$) in St. Vincent and the Grenadines in 1999 to that in 2000?
Offer a terse response. 17.26. What is the ratio of the Aid flow (current US$) in Mauritius in 1999 to that in 2001?
Offer a terse response. 14.04. What is the ratio of the Aid flow (current US$) in Moldova in 1999 to that in 2001?
Your answer should be compact. 1.88. What is the ratio of the Aid flow (current US$) in Myanmar in 1999 to that in 2001?
Offer a very short reply. 0.32. What is the ratio of the Aid flow (current US$) of St. Vincent and the Grenadines in 1999 to that in 2001?
Keep it short and to the point. 1.96. What is the ratio of the Aid flow (current US$) of Mauritius in 1999 to that in 2002?
Offer a very short reply. 1.63. What is the ratio of the Aid flow (current US$) in Moldova in 1999 to that in 2002?
Make the answer very short. 0.78. What is the ratio of the Aid flow (current US$) in Myanmar in 1999 to that in 2002?
Your answer should be very brief. 0.14. What is the ratio of the Aid flow (current US$) of Mauritius in 1999 to that in 2003?
Your answer should be compact. 62.43. What is the ratio of the Aid flow (current US$) in Moldova in 1999 to that in 2003?
Your response must be concise. 1.03. What is the ratio of the Aid flow (current US$) of Myanmar in 1999 to that in 2003?
Ensure brevity in your answer.  0.12. What is the ratio of the Aid flow (current US$) of St. Vincent and the Grenadines in 1999 to that in 2003?
Provide a succinct answer. 2.36. What is the ratio of the Aid flow (current US$) in Mauritius in 1999 to that in 2004?
Provide a succinct answer. 2.07. What is the ratio of the Aid flow (current US$) of Moldova in 1999 to that in 2004?
Your response must be concise. 0.87. What is the ratio of the Aid flow (current US$) in Myanmar in 1999 to that in 2004?
Provide a succinct answer. 0.11. What is the ratio of the Aid flow (current US$) of St. Vincent and the Grenadines in 1999 to that in 2004?
Provide a succinct answer. 2.08. What is the ratio of the Aid flow (current US$) of Mauritius in 2000 to that in 2001?
Your response must be concise. 1.57. What is the ratio of the Aid flow (current US$) of Moldova in 2000 to that in 2001?
Provide a succinct answer. 1.14. What is the ratio of the Aid flow (current US$) in Myanmar in 2000 to that in 2001?
Offer a very short reply. 0.42. What is the ratio of the Aid flow (current US$) in St. Vincent and the Grenadines in 2000 to that in 2001?
Offer a very short reply. 0.11. What is the ratio of the Aid flow (current US$) of Mauritius in 2000 to that in 2002?
Make the answer very short. 0.18. What is the ratio of the Aid flow (current US$) of Moldova in 2000 to that in 2002?
Provide a succinct answer. 0.47. What is the ratio of the Aid flow (current US$) of Myanmar in 2000 to that in 2002?
Provide a succinct answer. 0.18. What is the ratio of the Aid flow (current US$) in Mauritius in 2000 to that in 2003?
Your response must be concise. 6.98. What is the ratio of the Aid flow (current US$) of Moldova in 2000 to that in 2003?
Your answer should be very brief. 0.62. What is the ratio of the Aid flow (current US$) in Myanmar in 2000 to that in 2003?
Offer a very short reply. 0.15. What is the ratio of the Aid flow (current US$) in St. Vincent and the Grenadines in 2000 to that in 2003?
Offer a terse response. 0.14. What is the ratio of the Aid flow (current US$) in Mauritius in 2000 to that in 2004?
Make the answer very short. 0.23. What is the ratio of the Aid flow (current US$) of Moldova in 2000 to that in 2004?
Your answer should be very brief. 0.53. What is the ratio of the Aid flow (current US$) of Myanmar in 2000 to that in 2004?
Your response must be concise. 0.14. What is the ratio of the Aid flow (current US$) of St. Vincent and the Grenadines in 2000 to that in 2004?
Your answer should be very brief. 0.12. What is the ratio of the Aid flow (current US$) in Mauritius in 2001 to that in 2002?
Your response must be concise. 0.12. What is the ratio of the Aid flow (current US$) in Moldova in 2001 to that in 2002?
Make the answer very short. 0.41. What is the ratio of the Aid flow (current US$) in Myanmar in 2001 to that in 2002?
Make the answer very short. 0.44. What is the ratio of the Aid flow (current US$) of Mauritius in 2001 to that in 2003?
Keep it short and to the point. 4.45. What is the ratio of the Aid flow (current US$) of Moldova in 2001 to that in 2003?
Provide a short and direct response. 0.55. What is the ratio of the Aid flow (current US$) in Myanmar in 2001 to that in 2003?
Ensure brevity in your answer.  0.36. What is the ratio of the Aid flow (current US$) of St. Vincent and the Grenadines in 2001 to that in 2003?
Your answer should be very brief. 1.2. What is the ratio of the Aid flow (current US$) in Mauritius in 2001 to that in 2004?
Your response must be concise. 0.15. What is the ratio of the Aid flow (current US$) of Moldova in 2001 to that in 2004?
Offer a very short reply. 0.46. What is the ratio of the Aid flow (current US$) of Myanmar in 2001 to that in 2004?
Offer a very short reply. 0.35. What is the ratio of the Aid flow (current US$) of St. Vincent and the Grenadines in 2001 to that in 2004?
Your answer should be compact. 1.06. What is the ratio of the Aid flow (current US$) in Mauritius in 2002 to that in 2003?
Provide a succinct answer. 38.26. What is the ratio of the Aid flow (current US$) of Moldova in 2002 to that in 2003?
Offer a terse response. 1.33. What is the ratio of the Aid flow (current US$) of Myanmar in 2002 to that in 2003?
Ensure brevity in your answer.  0.82. What is the ratio of the Aid flow (current US$) in Mauritius in 2002 to that in 2004?
Provide a succinct answer. 1.27. What is the ratio of the Aid flow (current US$) in Moldova in 2002 to that in 2004?
Give a very brief answer. 1.12. What is the ratio of the Aid flow (current US$) of Myanmar in 2002 to that in 2004?
Offer a terse response. 0.78. What is the ratio of the Aid flow (current US$) in Mauritius in 2003 to that in 2004?
Your answer should be compact. 0.03. What is the ratio of the Aid flow (current US$) in Moldova in 2003 to that in 2004?
Make the answer very short. 0.84. What is the ratio of the Aid flow (current US$) of Myanmar in 2003 to that in 2004?
Offer a very short reply. 0.96. What is the ratio of the Aid flow (current US$) of St. Vincent and the Grenadines in 2003 to that in 2004?
Give a very brief answer. 0.88. What is the difference between the highest and the second highest Aid flow (current US$) of Mauritius?
Your response must be concise. 9.56e+06. What is the difference between the highest and the second highest Aid flow (current US$) in Moldova?
Keep it short and to the point. 1.23e+06. What is the difference between the highest and the second highest Aid flow (current US$) in St. Vincent and the Grenadines?
Offer a terse response. 7.74e+06. What is the difference between the highest and the lowest Aid flow (current US$) in Mauritius?
Ensure brevity in your answer.  2.89e+07. What is the difference between the highest and the lowest Aid flow (current US$) of Moldova?
Give a very brief answer. 6.63e+06. What is the difference between the highest and the lowest Aid flow (current US$) in Myanmar?
Give a very brief answer. 9.87e+06. What is the difference between the highest and the lowest Aid flow (current US$) in St. Vincent and the Grenadines?
Give a very brief answer. 1.50e+07. 